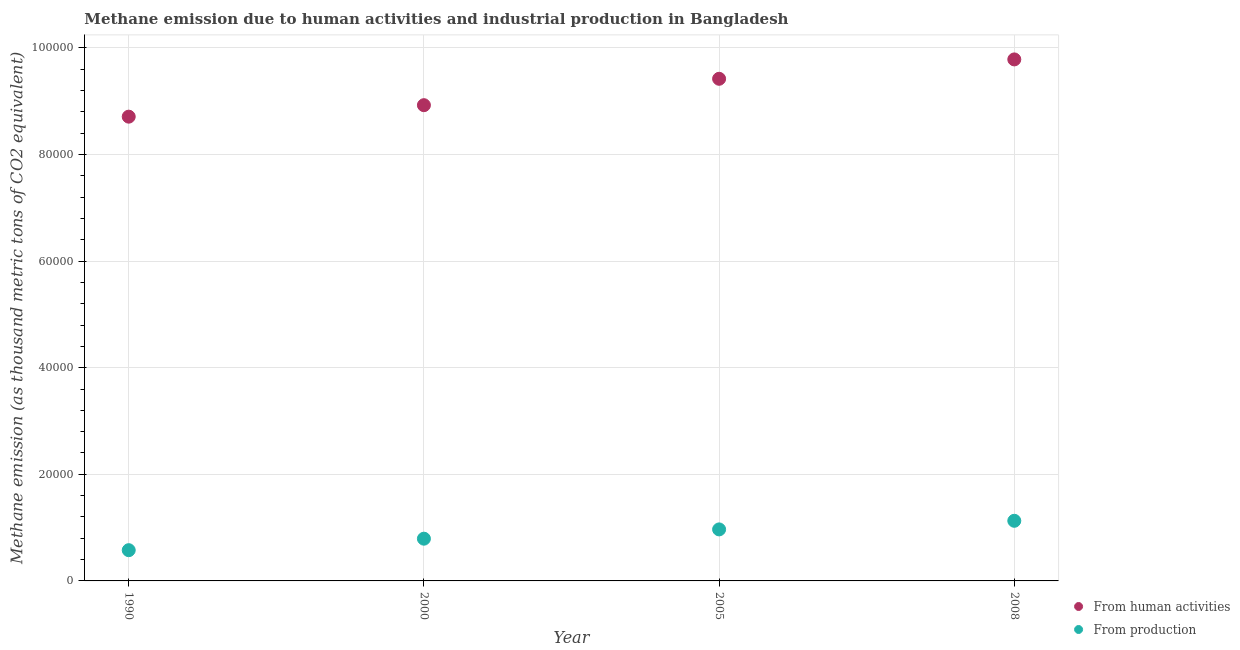How many different coloured dotlines are there?
Your answer should be very brief. 2. What is the amount of emissions generated from industries in 2000?
Offer a terse response. 7923.4. Across all years, what is the maximum amount of emissions generated from industries?
Keep it short and to the point. 1.13e+04. Across all years, what is the minimum amount of emissions generated from industries?
Provide a succinct answer. 5766.3. In which year was the amount of emissions from human activities minimum?
Offer a terse response. 1990. What is the total amount of emissions from human activities in the graph?
Provide a succinct answer. 3.68e+05. What is the difference between the amount of emissions from human activities in 2000 and that in 2008?
Your answer should be very brief. -8585. What is the difference between the amount of emissions from human activities in 2000 and the amount of emissions generated from industries in 2005?
Offer a terse response. 7.96e+04. What is the average amount of emissions from human activities per year?
Your response must be concise. 9.21e+04. In the year 2005, what is the difference between the amount of emissions from human activities and amount of emissions generated from industries?
Your answer should be compact. 8.45e+04. What is the ratio of the amount of emissions from human activities in 1990 to that in 2008?
Your answer should be compact. 0.89. Is the difference between the amount of emissions generated from industries in 1990 and 2005 greater than the difference between the amount of emissions from human activities in 1990 and 2005?
Provide a short and direct response. Yes. What is the difference between the highest and the second highest amount of emissions generated from industries?
Your answer should be compact. 1615.6. What is the difference between the highest and the lowest amount of emissions from human activities?
Offer a terse response. 1.07e+04. Is the sum of the amount of emissions generated from industries in 1990 and 2000 greater than the maximum amount of emissions from human activities across all years?
Provide a succinct answer. No. How many dotlines are there?
Offer a very short reply. 2. How many years are there in the graph?
Provide a succinct answer. 4. What is the difference between two consecutive major ticks on the Y-axis?
Provide a short and direct response. 2.00e+04. Does the graph contain any zero values?
Ensure brevity in your answer.  No. Does the graph contain grids?
Offer a terse response. Yes. Where does the legend appear in the graph?
Make the answer very short. Bottom right. How many legend labels are there?
Offer a terse response. 2. How are the legend labels stacked?
Make the answer very short. Vertical. What is the title of the graph?
Provide a succinct answer. Methane emission due to human activities and industrial production in Bangladesh. What is the label or title of the Y-axis?
Provide a short and direct response. Methane emission (as thousand metric tons of CO2 equivalent). What is the Methane emission (as thousand metric tons of CO2 equivalent) in From human activities in 1990?
Your response must be concise. 8.71e+04. What is the Methane emission (as thousand metric tons of CO2 equivalent) in From production in 1990?
Your answer should be compact. 5766.3. What is the Methane emission (as thousand metric tons of CO2 equivalent) of From human activities in 2000?
Give a very brief answer. 8.92e+04. What is the Methane emission (as thousand metric tons of CO2 equivalent) of From production in 2000?
Make the answer very short. 7923.4. What is the Methane emission (as thousand metric tons of CO2 equivalent) of From human activities in 2005?
Make the answer very short. 9.42e+04. What is the Methane emission (as thousand metric tons of CO2 equivalent) of From production in 2005?
Your response must be concise. 9663.6. What is the Methane emission (as thousand metric tons of CO2 equivalent) in From human activities in 2008?
Offer a very short reply. 9.78e+04. What is the Methane emission (as thousand metric tons of CO2 equivalent) of From production in 2008?
Provide a succinct answer. 1.13e+04. Across all years, what is the maximum Methane emission (as thousand metric tons of CO2 equivalent) of From human activities?
Keep it short and to the point. 9.78e+04. Across all years, what is the maximum Methane emission (as thousand metric tons of CO2 equivalent) of From production?
Provide a short and direct response. 1.13e+04. Across all years, what is the minimum Methane emission (as thousand metric tons of CO2 equivalent) of From human activities?
Ensure brevity in your answer.  8.71e+04. Across all years, what is the minimum Methane emission (as thousand metric tons of CO2 equivalent) of From production?
Keep it short and to the point. 5766.3. What is the total Methane emission (as thousand metric tons of CO2 equivalent) of From human activities in the graph?
Offer a very short reply. 3.68e+05. What is the total Methane emission (as thousand metric tons of CO2 equivalent) in From production in the graph?
Make the answer very short. 3.46e+04. What is the difference between the Methane emission (as thousand metric tons of CO2 equivalent) of From human activities in 1990 and that in 2000?
Ensure brevity in your answer.  -2153.8. What is the difference between the Methane emission (as thousand metric tons of CO2 equivalent) of From production in 1990 and that in 2000?
Your response must be concise. -2157.1. What is the difference between the Methane emission (as thousand metric tons of CO2 equivalent) in From human activities in 1990 and that in 2005?
Make the answer very short. -7104.5. What is the difference between the Methane emission (as thousand metric tons of CO2 equivalent) in From production in 1990 and that in 2005?
Make the answer very short. -3897.3. What is the difference between the Methane emission (as thousand metric tons of CO2 equivalent) in From human activities in 1990 and that in 2008?
Offer a very short reply. -1.07e+04. What is the difference between the Methane emission (as thousand metric tons of CO2 equivalent) of From production in 1990 and that in 2008?
Your answer should be very brief. -5512.9. What is the difference between the Methane emission (as thousand metric tons of CO2 equivalent) in From human activities in 2000 and that in 2005?
Provide a succinct answer. -4950.7. What is the difference between the Methane emission (as thousand metric tons of CO2 equivalent) of From production in 2000 and that in 2005?
Offer a very short reply. -1740.2. What is the difference between the Methane emission (as thousand metric tons of CO2 equivalent) in From human activities in 2000 and that in 2008?
Ensure brevity in your answer.  -8585. What is the difference between the Methane emission (as thousand metric tons of CO2 equivalent) in From production in 2000 and that in 2008?
Provide a succinct answer. -3355.8. What is the difference between the Methane emission (as thousand metric tons of CO2 equivalent) of From human activities in 2005 and that in 2008?
Offer a very short reply. -3634.3. What is the difference between the Methane emission (as thousand metric tons of CO2 equivalent) of From production in 2005 and that in 2008?
Provide a short and direct response. -1615.6. What is the difference between the Methane emission (as thousand metric tons of CO2 equivalent) in From human activities in 1990 and the Methane emission (as thousand metric tons of CO2 equivalent) in From production in 2000?
Your answer should be very brief. 7.92e+04. What is the difference between the Methane emission (as thousand metric tons of CO2 equivalent) in From human activities in 1990 and the Methane emission (as thousand metric tons of CO2 equivalent) in From production in 2005?
Give a very brief answer. 7.74e+04. What is the difference between the Methane emission (as thousand metric tons of CO2 equivalent) of From human activities in 1990 and the Methane emission (as thousand metric tons of CO2 equivalent) of From production in 2008?
Provide a short and direct response. 7.58e+04. What is the difference between the Methane emission (as thousand metric tons of CO2 equivalent) in From human activities in 2000 and the Methane emission (as thousand metric tons of CO2 equivalent) in From production in 2005?
Your response must be concise. 7.96e+04. What is the difference between the Methane emission (as thousand metric tons of CO2 equivalent) in From human activities in 2000 and the Methane emission (as thousand metric tons of CO2 equivalent) in From production in 2008?
Give a very brief answer. 7.80e+04. What is the difference between the Methane emission (as thousand metric tons of CO2 equivalent) of From human activities in 2005 and the Methane emission (as thousand metric tons of CO2 equivalent) of From production in 2008?
Provide a succinct answer. 8.29e+04. What is the average Methane emission (as thousand metric tons of CO2 equivalent) of From human activities per year?
Offer a very short reply. 9.21e+04. What is the average Methane emission (as thousand metric tons of CO2 equivalent) of From production per year?
Keep it short and to the point. 8658.12. In the year 1990, what is the difference between the Methane emission (as thousand metric tons of CO2 equivalent) of From human activities and Methane emission (as thousand metric tons of CO2 equivalent) of From production?
Your response must be concise. 8.13e+04. In the year 2000, what is the difference between the Methane emission (as thousand metric tons of CO2 equivalent) of From human activities and Methane emission (as thousand metric tons of CO2 equivalent) of From production?
Your answer should be compact. 8.13e+04. In the year 2005, what is the difference between the Methane emission (as thousand metric tons of CO2 equivalent) of From human activities and Methane emission (as thousand metric tons of CO2 equivalent) of From production?
Keep it short and to the point. 8.45e+04. In the year 2008, what is the difference between the Methane emission (as thousand metric tons of CO2 equivalent) in From human activities and Methane emission (as thousand metric tons of CO2 equivalent) in From production?
Your answer should be very brief. 8.65e+04. What is the ratio of the Methane emission (as thousand metric tons of CO2 equivalent) in From human activities in 1990 to that in 2000?
Provide a succinct answer. 0.98. What is the ratio of the Methane emission (as thousand metric tons of CO2 equivalent) of From production in 1990 to that in 2000?
Keep it short and to the point. 0.73. What is the ratio of the Methane emission (as thousand metric tons of CO2 equivalent) in From human activities in 1990 to that in 2005?
Your response must be concise. 0.92. What is the ratio of the Methane emission (as thousand metric tons of CO2 equivalent) in From production in 1990 to that in 2005?
Make the answer very short. 0.6. What is the ratio of the Methane emission (as thousand metric tons of CO2 equivalent) of From human activities in 1990 to that in 2008?
Your answer should be very brief. 0.89. What is the ratio of the Methane emission (as thousand metric tons of CO2 equivalent) in From production in 1990 to that in 2008?
Your answer should be compact. 0.51. What is the ratio of the Methane emission (as thousand metric tons of CO2 equivalent) of From human activities in 2000 to that in 2005?
Your answer should be compact. 0.95. What is the ratio of the Methane emission (as thousand metric tons of CO2 equivalent) of From production in 2000 to that in 2005?
Provide a succinct answer. 0.82. What is the ratio of the Methane emission (as thousand metric tons of CO2 equivalent) in From human activities in 2000 to that in 2008?
Provide a succinct answer. 0.91. What is the ratio of the Methane emission (as thousand metric tons of CO2 equivalent) in From production in 2000 to that in 2008?
Give a very brief answer. 0.7. What is the ratio of the Methane emission (as thousand metric tons of CO2 equivalent) in From human activities in 2005 to that in 2008?
Ensure brevity in your answer.  0.96. What is the ratio of the Methane emission (as thousand metric tons of CO2 equivalent) of From production in 2005 to that in 2008?
Your response must be concise. 0.86. What is the difference between the highest and the second highest Methane emission (as thousand metric tons of CO2 equivalent) in From human activities?
Your answer should be compact. 3634.3. What is the difference between the highest and the second highest Methane emission (as thousand metric tons of CO2 equivalent) of From production?
Keep it short and to the point. 1615.6. What is the difference between the highest and the lowest Methane emission (as thousand metric tons of CO2 equivalent) of From human activities?
Provide a short and direct response. 1.07e+04. What is the difference between the highest and the lowest Methane emission (as thousand metric tons of CO2 equivalent) of From production?
Make the answer very short. 5512.9. 